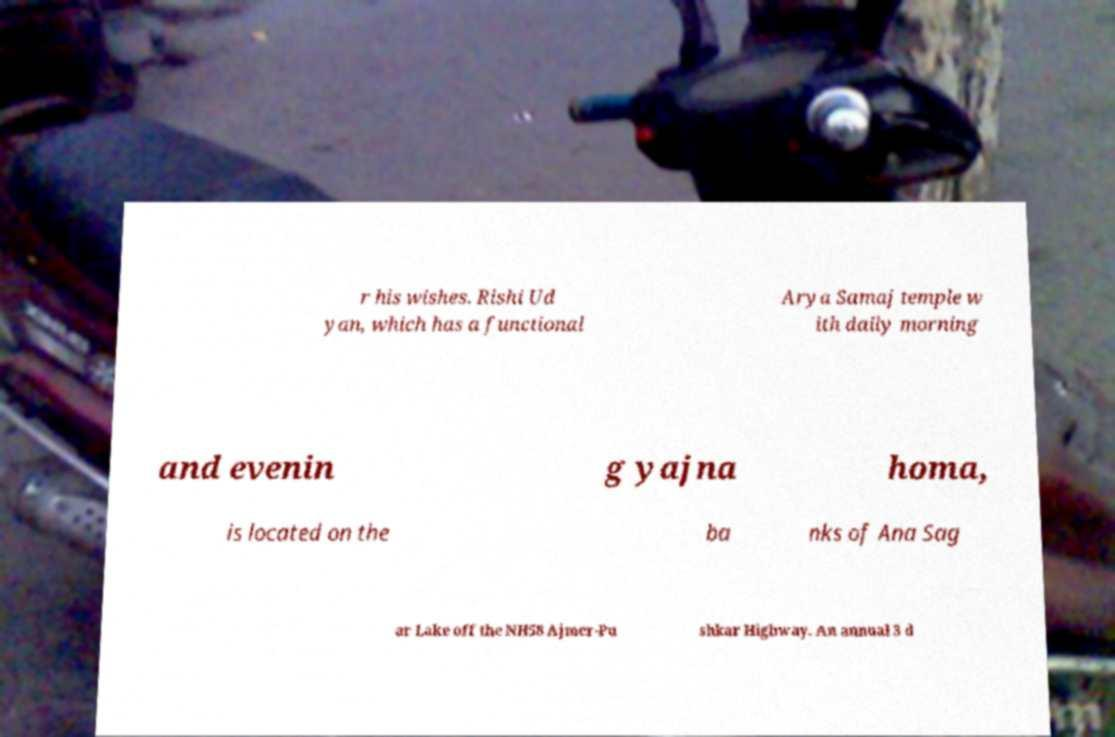Could you extract and type out the text from this image? r his wishes. Rishi Ud yan, which has a functional Arya Samaj temple w ith daily morning and evenin g yajna homa, is located on the ba nks of Ana Sag ar Lake off the NH58 Ajmer-Pu shkar Highway. An annual 3 d 